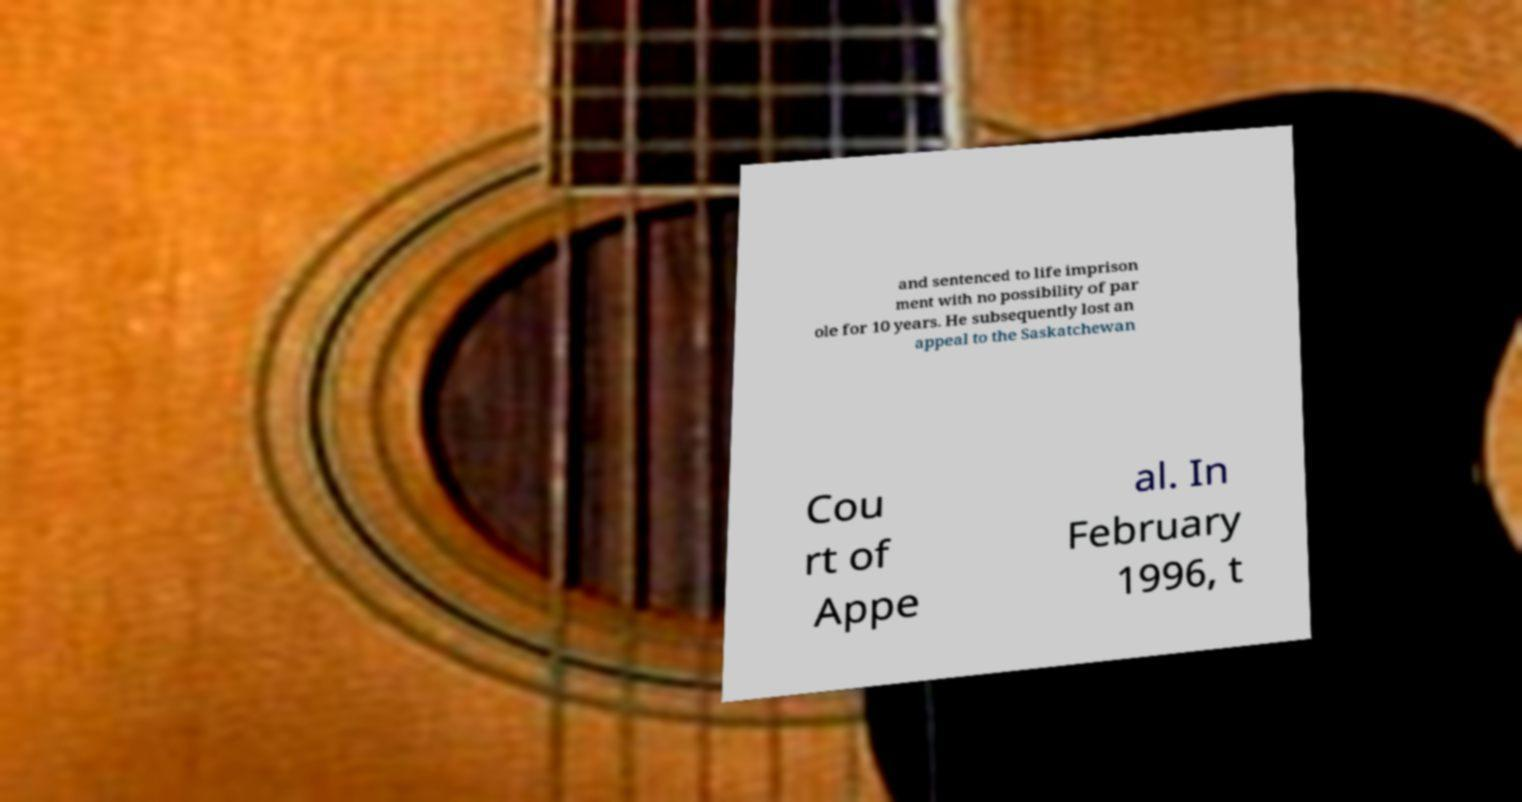Please identify and transcribe the text found in this image. and sentenced to life imprison ment with no possibility of par ole for 10 years. He subsequently lost an appeal to the Saskatchewan Cou rt of Appe al. In February 1996, t 